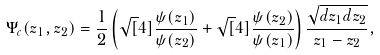Convert formula to latex. <formula><loc_0><loc_0><loc_500><loc_500>\Psi _ { c } ( z _ { 1 } , z _ { 2 } ) = \frac { 1 } { 2 } \left ( \sqrt { [ } 4 ] { \frac { \psi ( z _ { 1 } ) } { \psi ( z _ { 2 } ) } } + \sqrt { [ } 4 ] { \frac { \psi ( z _ { 2 } ) } { \psi ( z _ { 1 } ) } } \right ) \frac { \sqrt { d z _ { 1 } d z _ { 2 } } } { z _ { 1 } - z _ { 2 } } ,</formula> 